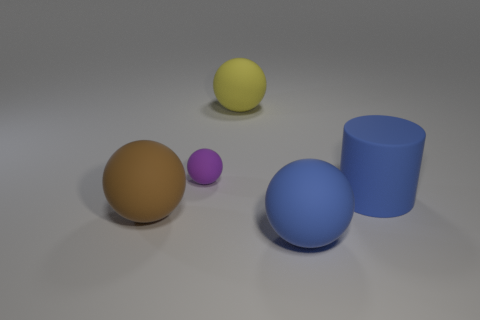There is a thing that is the same color as the cylinder; what shape is it?
Provide a short and direct response. Sphere. What number of objects are either big rubber spheres on the left side of the purple matte ball or brown metallic blocks?
Offer a very short reply. 1. How many other objects are there of the same size as the purple rubber thing?
Offer a terse response. 0. Are there an equal number of cylinders that are to the left of the yellow object and blue rubber cylinders that are on the right side of the small purple sphere?
Offer a very short reply. No. What is the color of the tiny thing that is the same shape as the big brown thing?
Provide a succinct answer. Purple. There is a matte thing in front of the brown ball; is its color the same as the large rubber cylinder?
Provide a short and direct response. Yes. The yellow matte object that is the same shape as the purple thing is what size?
Provide a succinct answer. Large. How many other big blue spheres are made of the same material as the large blue sphere?
Keep it short and to the point. 0. There is a object right of the blue thing in front of the blue matte cylinder; are there any blue things that are on the left side of it?
Your answer should be compact. Yes. The yellow object has what shape?
Give a very brief answer. Sphere. 